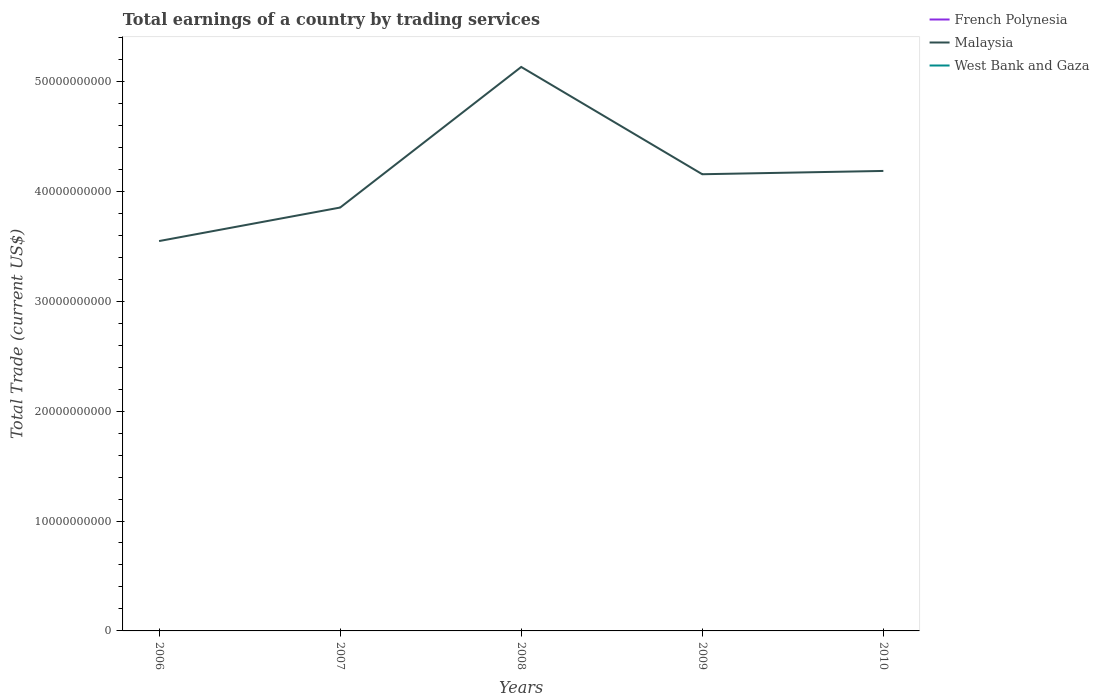How many different coloured lines are there?
Your response must be concise. 1. Does the line corresponding to Malaysia intersect with the line corresponding to French Polynesia?
Ensure brevity in your answer.  No. Is the number of lines equal to the number of legend labels?
Offer a very short reply. No. What is the total total earnings in Malaysia in the graph?
Your response must be concise. -3.03e+09. What is the difference between the highest and the second highest total earnings in Malaysia?
Your answer should be very brief. 1.58e+1. What is the difference between the highest and the lowest total earnings in Malaysia?
Your response must be concise. 2. How many years are there in the graph?
Your answer should be very brief. 5. What is the difference between two consecutive major ticks on the Y-axis?
Offer a very short reply. 1.00e+1. Are the values on the major ticks of Y-axis written in scientific E-notation?
Provide a succinct answer. No. Does the graph contain grids?
Your answer should be very brief. No. What is the title of the graph?
Make the answer very short. Total earnings of a country by trading services. What is the label or title of the Y-axis?
Provide a succinct answer. Total Trade (current US$). What is the Total Trade (current US$) in French Polynesia in 2006?
Offer a very short reply. 0. What is the Total Trade (current US$) of Malaysia in 2006?
Provide a succinct answer. 3.55e+1. What is the Total Trade (current US$) of Malaysia in 2007?
Make the answer very short. 3.85e+1. What is the Total Trade (current US$) in West Bank and Gaza in 2007?
Make the answer very short. 0. What is the Total Trade (current US$) of Malaysia in 2008?
Your answer should be compact. 5.13e+1. What is the Total Trade (current US$) in West Bank and Gaza in 2008?
Offer a very short reply. 0. What is the Total Trade (current US$) of Malaysia in 2009?
Your answer should be compact. 4.16e+1. What is the Total Trade (current US$) of West Bank and Gaza in 2009?
Offer a very short reply. 0. What is the Total Trade (current US$) of French Polynesia in 2010?
Keep it short and to the point. 0. What is the Total Trade (current US$) of Malaysia in 2010?
Your answer should be very brief. 4.19e+1. Across all years, what is the maximum Total Trade (current US$) of Malaysia?
Give a very brief answer. 5.13e+1. Across all years, what is the minimum Total Trade (current US$) of Malaysia?
Provide a succinct answer. 3.55e+1. What is the total Total Trade (current US$) of French Polynesia in the graph?
Keep it short and to the point. 0. What is the total Total Trade (current US$) in Malaysia in the graph?
Give a very brief answer. 2.09e+11. What is the difference between the Total Trade (current US$) of Malaysia in 2006 and that in 2007?
Your answer should be compact. -3.05e+09. What is the difference between the Total Trade (current US$) in Malaysia in 2006 and that in 2008?
Your answer should be very brief. -1.58e+1. What is the difference between the Total Trade (current US$) in Malaysia in 2006 and that in 2009?
Provide a short and direct response. -6.08e+09. What is the difference between the Total Trade (current US$) of Malaysia in 2006 and that in 2010?
Your answer should be very brief. -6.38e+09. What is the difference between the Total Trade (current US$) of Malaysia in 2007 and that in 2008?
Provide a short and direct response. -1.28e+1. What is the difference between the Total Trade (current US$) in Malaysia in 2007 and that in 2009?
Make the answer very short. -3.03e+09. What is the difference between the Total Trade (current US$) in Malaysia in 2007 and that in 2010?
Provide a short and direct response. -3.33e+09. What is the difference between the Total Trade (current US$) in Malaysia in 2008 and that in 2009?
Your answer should be very brief. 9.76e+09. What is the difference between the Total Trade (current US$) of Malaysia in 2008 and that in 2010?
Your answer should be very brief. 9.46e+09. What is the difference between the Total Trade (current US$) of Malaysia in 2009 and that in 2010?
Keep it short and to the point. -3.00e+08. What is the average Total Trade (current US$) of Malaysia per year?
Offer a very short reply. 4.17e+1. What is the average Total Trade (current US$) in West Bank and Gaza per year?
Offer a very short reply. 0. What is the ratio of the Total Trade (current US$) of Malaysia in 2006 to that in 2007?
Ensure brevity in your answer.  0.92. What is the ratio of the Total Trade (current US$) in Malaysia in 2006 to that in 2008?
Keep it short and to the point. 0.69. What is the ratio of the Total Trade (current US$) of Malaysia in 2006 to that in 2009?
Provide a short and direct response. 0.85. What is the ratio of the Total Trade (current US$) in Malaysia in 2006 to that in 2010?
Offer a very short reply. 0.85. What is the ratio of the Total Trade (current US$) in Malaysia in 2007 to that in 2008?
Your answer should be compact. 0.75. What is the ratio of the Total Trade (current US$) of Malaysia in 2007 to that in 2009?
Your response must be concise. 0.93. What is the ratio of the Total Trade (current US$) of Malaysia in 2007 to that in 2010?
Give a very brief answer. 0.92. What is the ratio of the Total Trade (current US$) of Malaysia in 2008 to that in 2009?
Offer a very short reply. 1.23. What is the ratio of the Total Trade (current US$) of Malaysia in 2008 to that in 2010?
Make the answer very short. 1.23. What is the ratio of the Total Trade (current US$) in Malaysia in 2009 to that in 2010?
Offer a terse response. 0.99. What is the difference between the highest and the second highest Total Trade (current US$) in Malaysia?
Ensure brevity in your answer.  9.46e+09. What is the difference between the highest and the lowest Total Trade (current US$) of Malaysia?
Your answer should be very brief. 1.58e+1. 